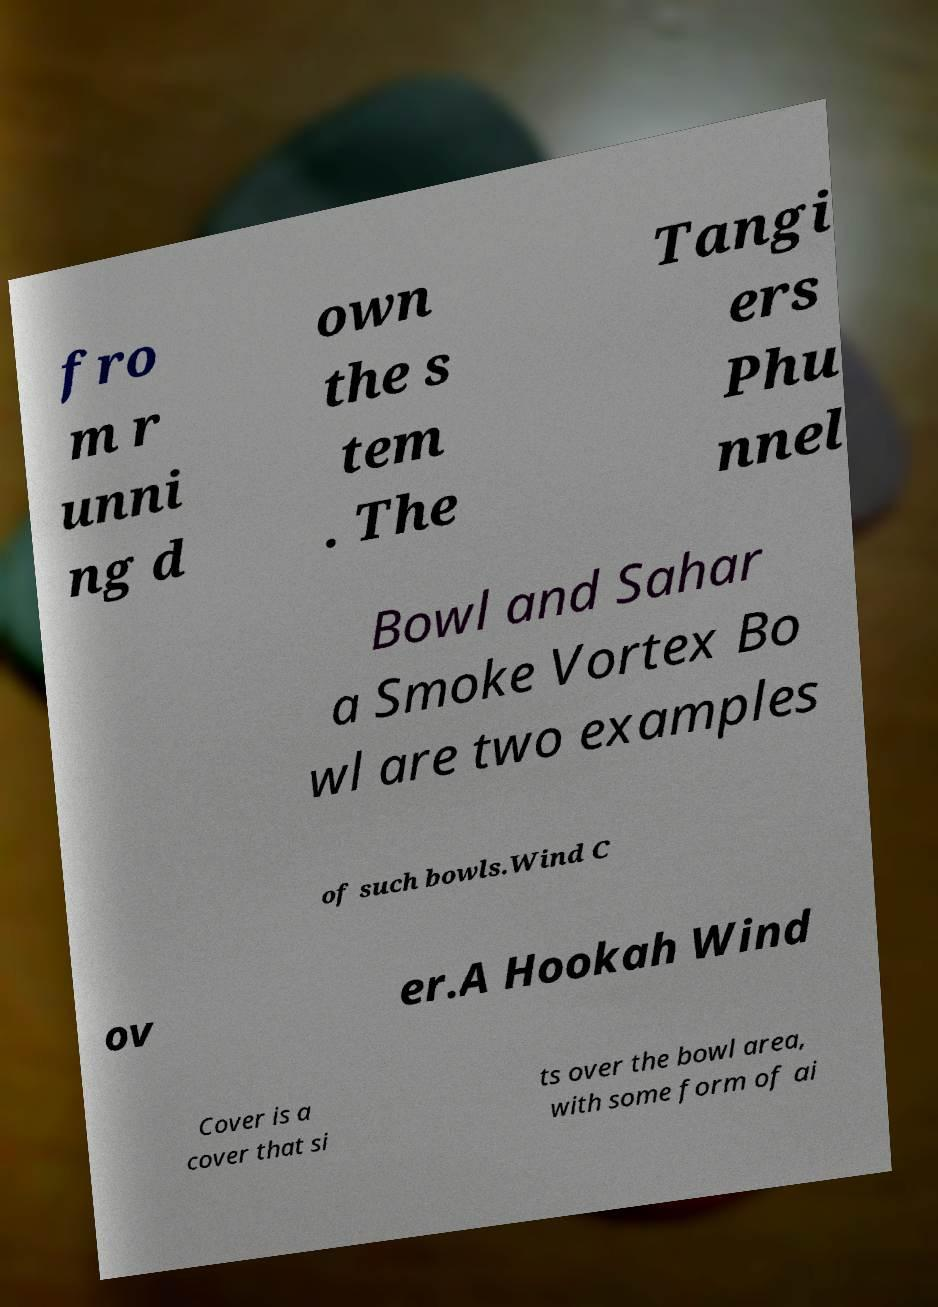Can you accurately transcribe the text from the provided image for me? fro m r unni ng d own the s tem . The Tangi ers Phu nnel Bowl and Sahar a Smoke Vortex Bo wl are two examples of such bowls.Wind C ov er.A Hookah Wind Cover is a cover that si ts over the bowl area, with some form of ai 